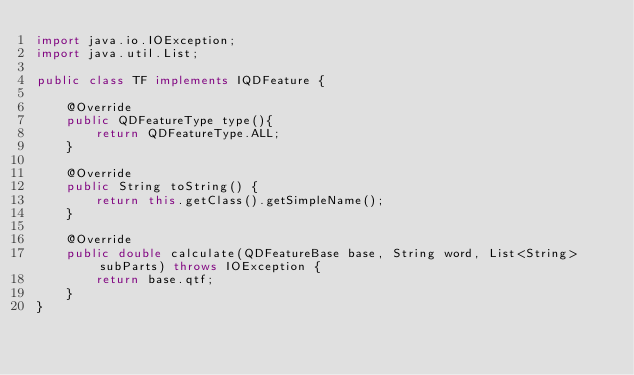Convert code to text. <code><loc_0><loc_0><loc_500><loc_500><_Java_>import java.io.IOException;
import java.util.List;

public class TF implements IQDFeature {

    @Override
    public QDFeatureType type(){
        return QDFeatureType.ALL;
    }

    @Override
    public String toString() {
        return this.getClass().getSimpleName();
    }

    @Override
    public double calculate(QDFeatureBase base, String word, List<String> subParts) throws IOException {
        return base.qtf;
    }
}
</code> 